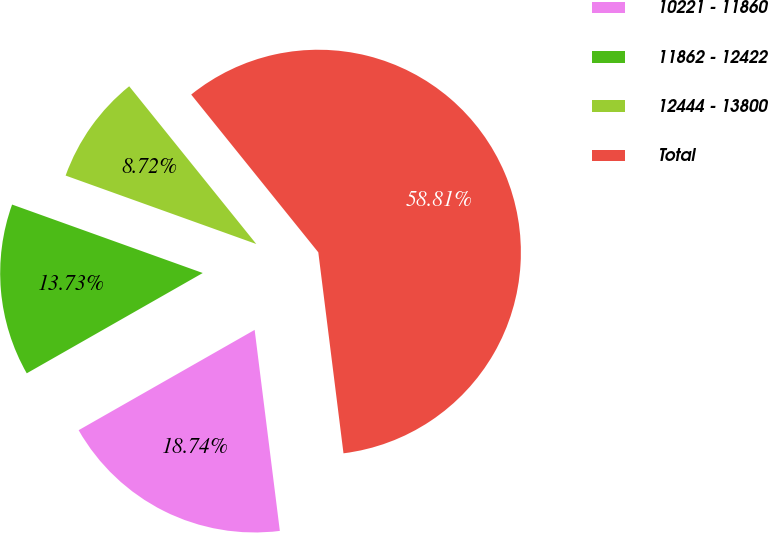<chart> <loc_0><loc_0><loc_500><loc_500><pie_chart><fcel>10221 - 11860<fcel>11862 - 12422<fcel>12444 - 13800<fcel>Total<nl><fcel>18.74%<fcel>13.73%<fcel>8.72%<fcel>58.81%<nl></chart> 